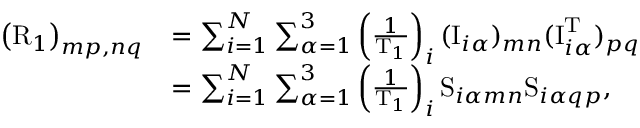Convert formula to latex. <formula><loc_0><loc_0><loc_500><loc_500>\begin{array} { r l } { \left ( R _ { 1 } \right ) _ { m p , n q } } & { = \sum _ { i = 1 } ^ { N } \sum _ { \alpha = 1 } ^ { 3 } \left ( \frac { 1 } { T _ { 1 } } \right ) _ { i } ( I _ { i \alpha } ) _ { m n } ( I _ { i \alpha } ^ { T } ) _ { p q } } \\ & { = \sum _ { i = 1 } ^ { N } \sum _ { \alpha = 1 } ^ { 3 } \left ( \frac { 1 } { T _ { 1 } } \right ) _ { i } S _ { i \alpha m n } S _ { i \alpha q p } , } \end{array}</formula> 